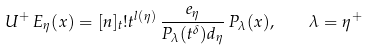<formula> <loc_0><loc_0><loc_500><loc_500>U ^ { + } \, E _ { \eta } ( x ) = [ n ] _ { t } ! t ^ { l ( \eta ) } \, \frac { e _ { \eta } } { P _ { \lambda } ( t ^ { \delta } ) d _ { \eta } } \, P _ { \lambda } ( x ) , \quad \lambda = \eta ^ { + }</formula> 